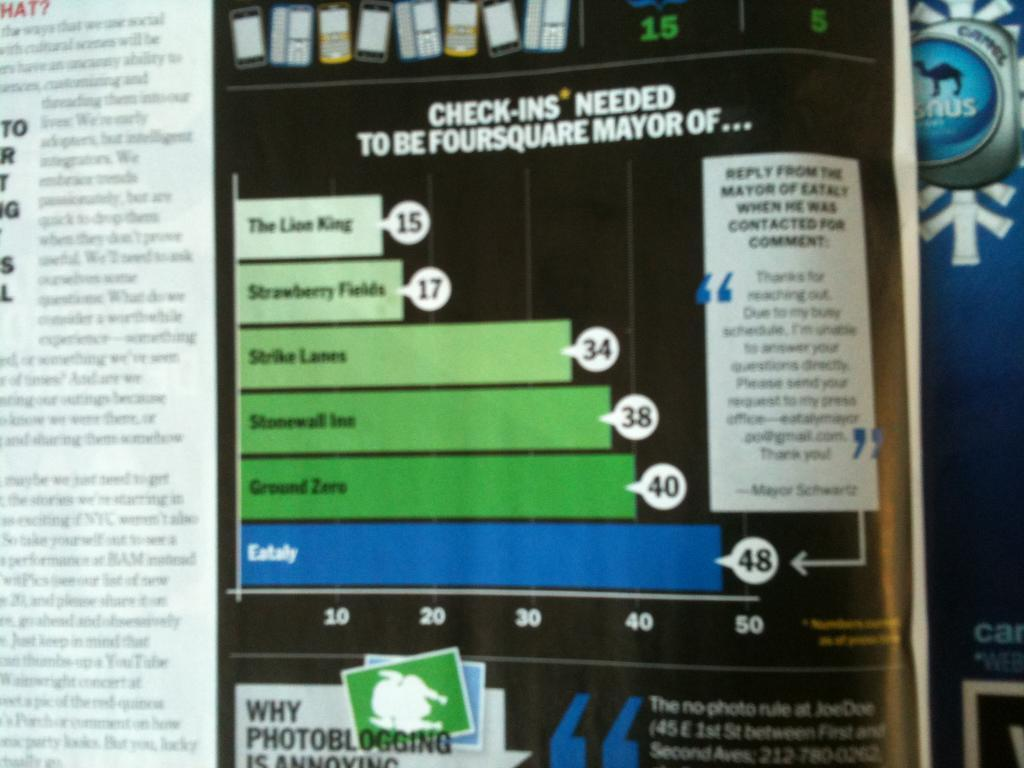Provide a one-sentence caption for the provided image. Magazine that includes check ins needed to be foursquare mayor of. 